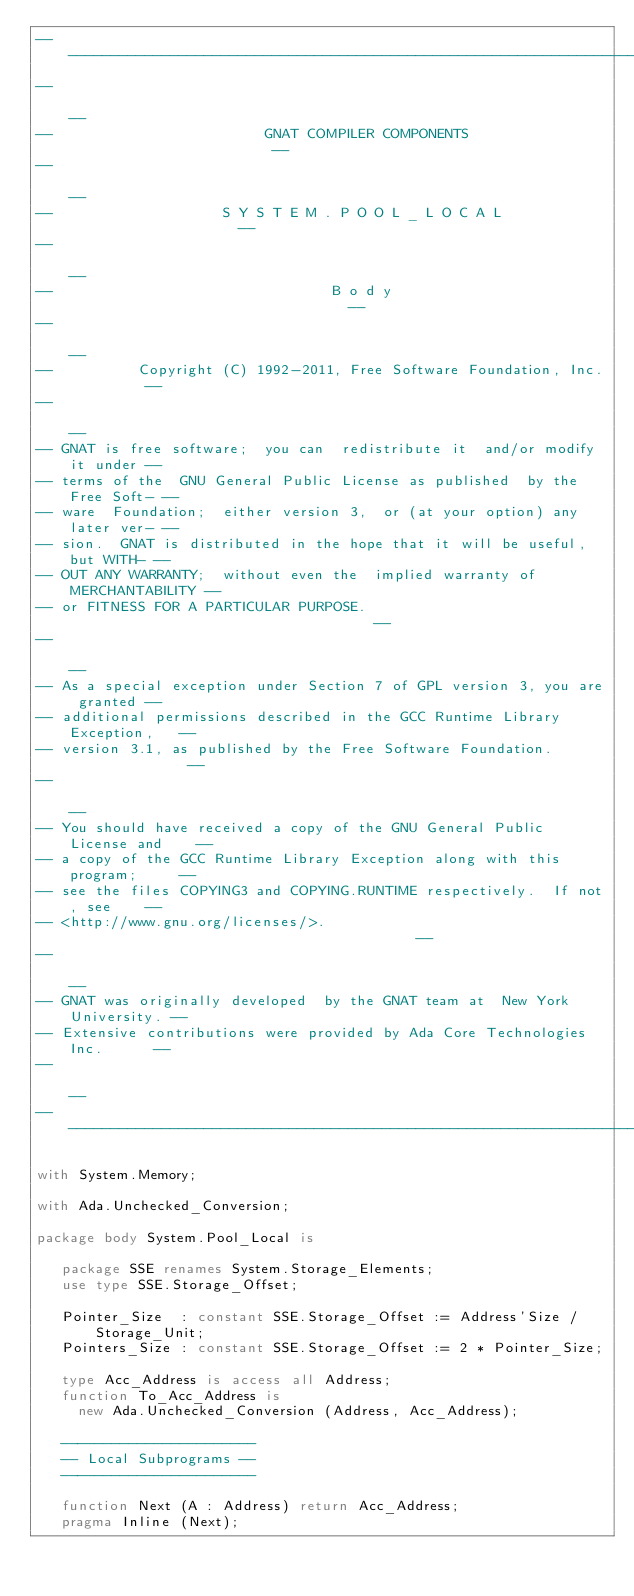<code> <loc_0><loc_0><loc_500><loc_500><_Ada_>------------------------------------------------------------------------------
--                                                                          --
--                         GNAT COMPILER COMPONENTS                         --
--                                                                          --
--                    S Y S T E M . P O O L _ L O C A L                     --
--                                                                          --
--                                 B o d y                                  --
--                                                                          --
--          Copyright (C) 1992-2011, Free Software Foundation, Inc.         --
--                                                                          --
-- GNAT is free software;  you can  redistribute it  and/or modify it under --
-- terms of the  GNU General Public License as published  by the Free Soft- --
-- ware  Foundation;  either version 3,  or (at your option) any later ver- --
-- sion.  GNAT is distributed in the hope that it will be useful, but WITH- --
-- OUT ANY WARRANTY;  without even the  implied warranty of MERCHANTABILITY --
-- or FITNESS FOR A PARTICULAR PURPOSE.                                     --
--                                                                          --
-- As a special exception under Section 7 of GPL version 3, you are granted --
-- additional permissions described in the GCC Runtime Library Exception,   --
-- version 3.1, as published by the Free Software Foundation.               --
--                                                                          --
-- You should have received a copy of the GNU General Public License and    --
-- a copy of the GCC Runtime Library Exception along with this program;     --
-- see the files COPYING3 and COPYING.RUNTIME respectively.  If not, see    --
-- <http://www.gnu.org/licenses/>.                                          --
--                                                                          --
-- GNAT was originally developed  by the GNAT team at  New York University. --
-- Extensive contributions were provided by Ada Core Technologies Inc.      --
--                                                                          --
------------------------------------------------------------------------------

with System.Memory;

with Ada.Unchecked_Conversion;

package body System.Pool_Local is

   package SSE renames System.Storage_Elements;
   use type SSE.Storage_Offset;

   Pointer_Size  : constant SSE.Storage_Offset := Address'Size / Storage_Unit;
   Pointers_Size : constant SSE.Storage_Offset := 2 * Pointer_Size;

   type Acc_Address is access all Address;
   function To_Acc_Address is
     new Ada.Unchecked_Conversion (Address, Acc_Address);

   -----------------------
   -- Local Subprograms --
   -----------------------

   function Next (A : Address) return Acc_Address;
   pragma Inline (Next);</code> 